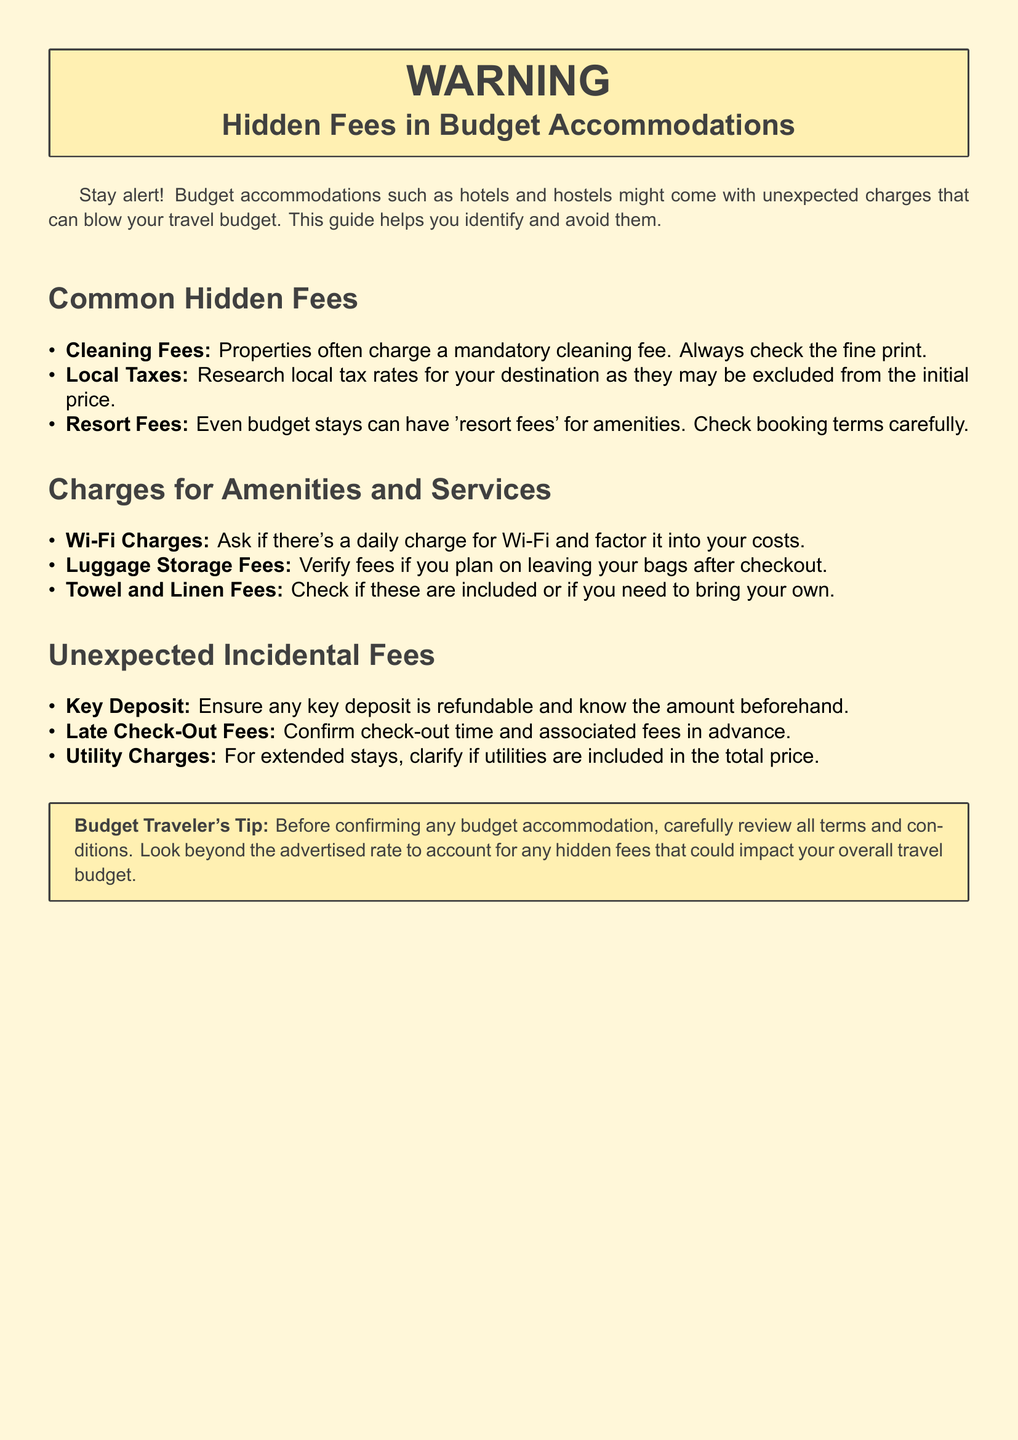What are common hidden fees in budget accommodations? The document lists common hidden fees including cleaning fees, local taxes, and resort fees.
Answer: Cleaning fees, local taxes, resort fees What should you check if you plan on leaving your bags after checkout? The document advises verifying the fees for luggage storage in that situation.
Answer: Luggage storage fees What type of charge may apply for staying in budget accommodations? The text suggests that some budget stays may include charges for amenities and services.
Answer: Charges for amenities and services What is a tip provided in the document for budget travelers? A warning label offers advice to carefully review all terms and conditions before confirming accommodations.
Answer: Review all terms and conditions carefully What might a property charge as a mandatory fee? The document mentions that properties often charge a mandatory cleaning fee.
Answer: Cleaning fee What should you confirm in advance regarding check-out? It is important to confirm the check-out time and associated fees beforehand according to the document.
Answer: Check-out time and fees What might be included in utility charges for extended stays? The document states that it's important to clarify if utilities are included in the total price.
Answer: Utilities What could be refundable when you stay at a budget accommodation? The text indicates that any key deposit should be refundable, and the amount should be known beforehand.
Answer: Key deposit 